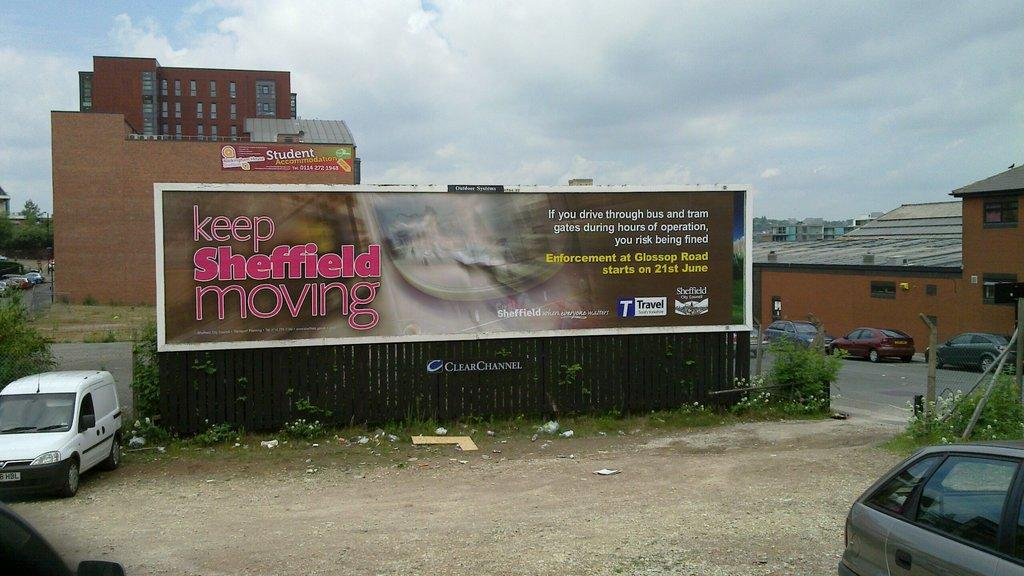<image>
Give a short and clear explanation of the subsequent image. a billboard that says 'keep sheffield moving' on it in red 